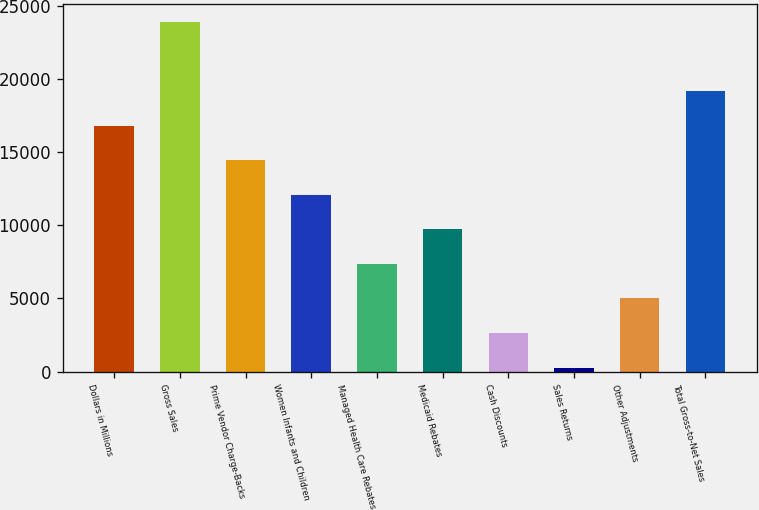Convert chart to OTSL. <chart><loc_0><loc_0><loc_500><loc_500><bar_chart><fcel>Dollars in Millions<fcel>Gross Sales<fcel>Prime Vendor Charge-Backs<fcel>Women Infants and Children<fcel>Managed Health Care Rebates<fcel>Medicaid Rebates<fcel>Cash Discounts<fcel>Sales Returns<fcel>Other Adjustments<fcel>Total Gross-to-Net Sales<nl><fcel>16810<fcel>23896<fcel>14448<fcel>12086<fcel>7362<fcel>9724<fcel>2638<fcel>276<fcel>5000<fcel>19172<nl></chart> 